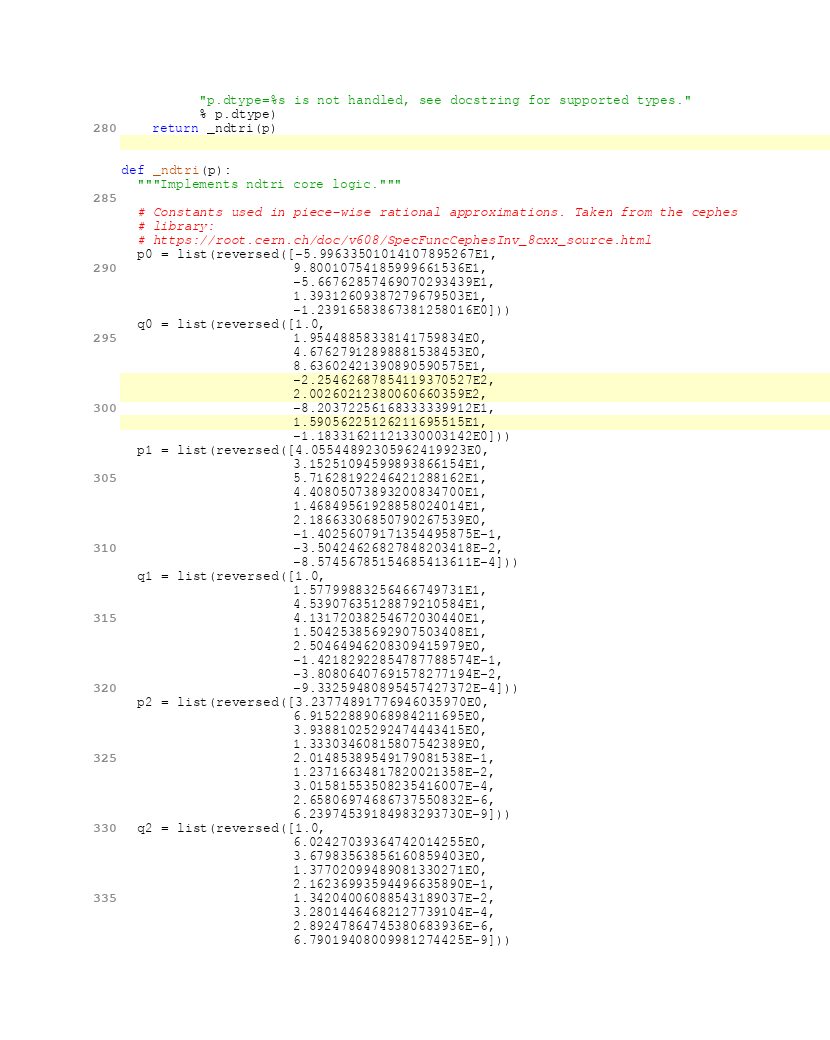Convert code to text. <code><loc_0><loc_0><loc_500><loc_500><_Python_>          "p.dtype=%s is not handled, see docstring for supported types."
          % p.dtype)
    return _ndtri(p)


def _ndtri(p):
  """Implements ndtri core logic."""

  # Constants used in piece-wise rational approximations. Taken from the cephes
  # library:
  # https://root.cern.ch/doc/v608/SpecFuncCephesInv_8cxx_source.html
  p0 = list(reversed([-5.99633501014107895267E1,
                      9.80010754185999661536E1,
                      -5.66762857469070293439E1,
                      1.39312609387279679503E1,
                      -1.23916583867381258016E0]))
  q0 = list(reversed([1.0,
                      1.95448858338141759834E0,
                      4.67627912898881538453E0,
                      8.63602421390890590575E1,
                      -2.25462687854119370527E2,
                      2.00260212380060660359E2,
                      -8.20372256168333339912E1,
                      1.59056225126211695515E1,
                      -1.18331621121330003142E0]))
  p1 = list(reversed([4.05544892305962419923E0,
                      3.15251094599893866154E1,
                      5.71628192246421288162E1,
                      4.40805073893200834700E1,
                      1.46849561928858024014E1,
                      2.18663306850790267539E0,
                      -1.40256079171354495875E-1,
                      -3.50424626827848203418E-2,
                      -8.57456785154685413611E-4]))
  q1 = list(reversed([1.0,
                      1.57799883256466749731E1,
                      4.53907635128879210584E1,
                      4.13172038254672030440E1,
                      1.50425385692907503408E1,
                      2.50464946208309415979E0,
                      -1.42182922854787788574E-1,
                      -3.80806407691578277194E-2,
                      -9.33259480895457427372E-4]))
  p2 = list(reversed([3.23774891776946035970E0,
                      6.91522889068984211695E0,
                      3.93881025292474443415E0,
                      1.33303460815807542389E0,
                      2.01485389549179081538E-1,
                      1.23716634817820021358E-2,
                      3.01581553508235416007E-4,
                      2.65806974686737550832E-6,
                      6.23974539184983293730E-9]))
  q2 = list(reversed([1.0,
                      6.02427039364742014255E0,
                      3.67983563856160859403E0,
                      1.37702099489081330271E0,
                      2.16236993594496635890E-1,
                      1.34204006088543189037E-2,
                      3.28014464682127739104E-4,
                      2.89247864745380683936E-6,
                      6.79019408009981274425E-9]))
</code> 